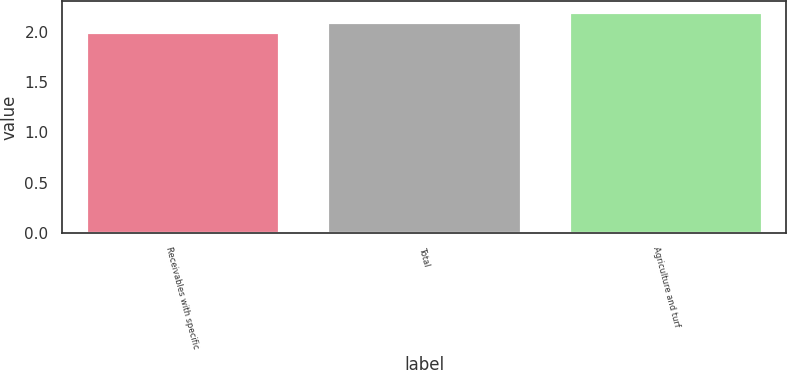<chart> <loc_0><loc_0><loc_500><loc_500><bar_chart><fcel>Receivables with specific<fcel>Total<fcel>Agriculture and turf<nl><fcel>2<fcel>2.1<fcel>2.2<nl></chart> 